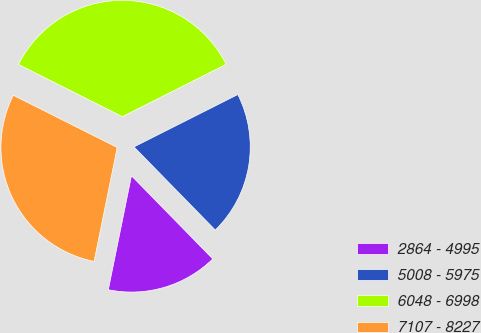Convert chart to OTSL. <chart><loc_0><loc_0><loc_500><loc_500><pie_chart><fcel>2864 - 4995<fcel>5008 - 5975<fcel>6048 - 6998<fcel>7107 - 8227<nl><fcel>15.51%<fcel>20.11%<fcel>35.16%<fcel>29.22%<nl></chart> 